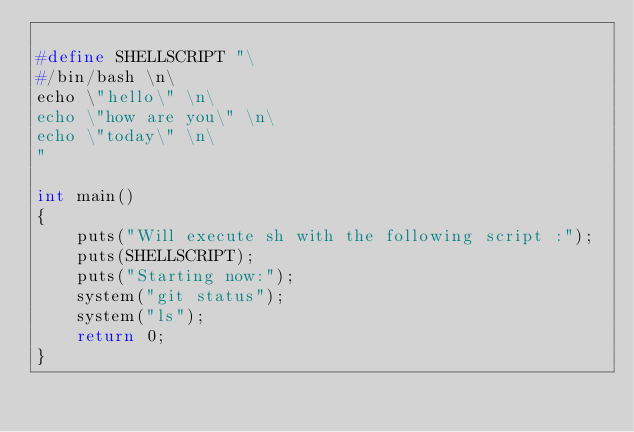<code> <loc_0><loc_0><loc_500><loc_500><_C_>
#define SHELLSCRIPT "\
#/bin/bash \n\
echo \"hello\" \n\
echo \"how are you\" \n\
echo \"today\" \n\
"

int main()
{
    puts("Will execute sh with the following script :");
    puts(SHELLSCRIPT);
    puts("Starting now:");
    system("git status");
    system("ls");
    return 0;
}
</code> 